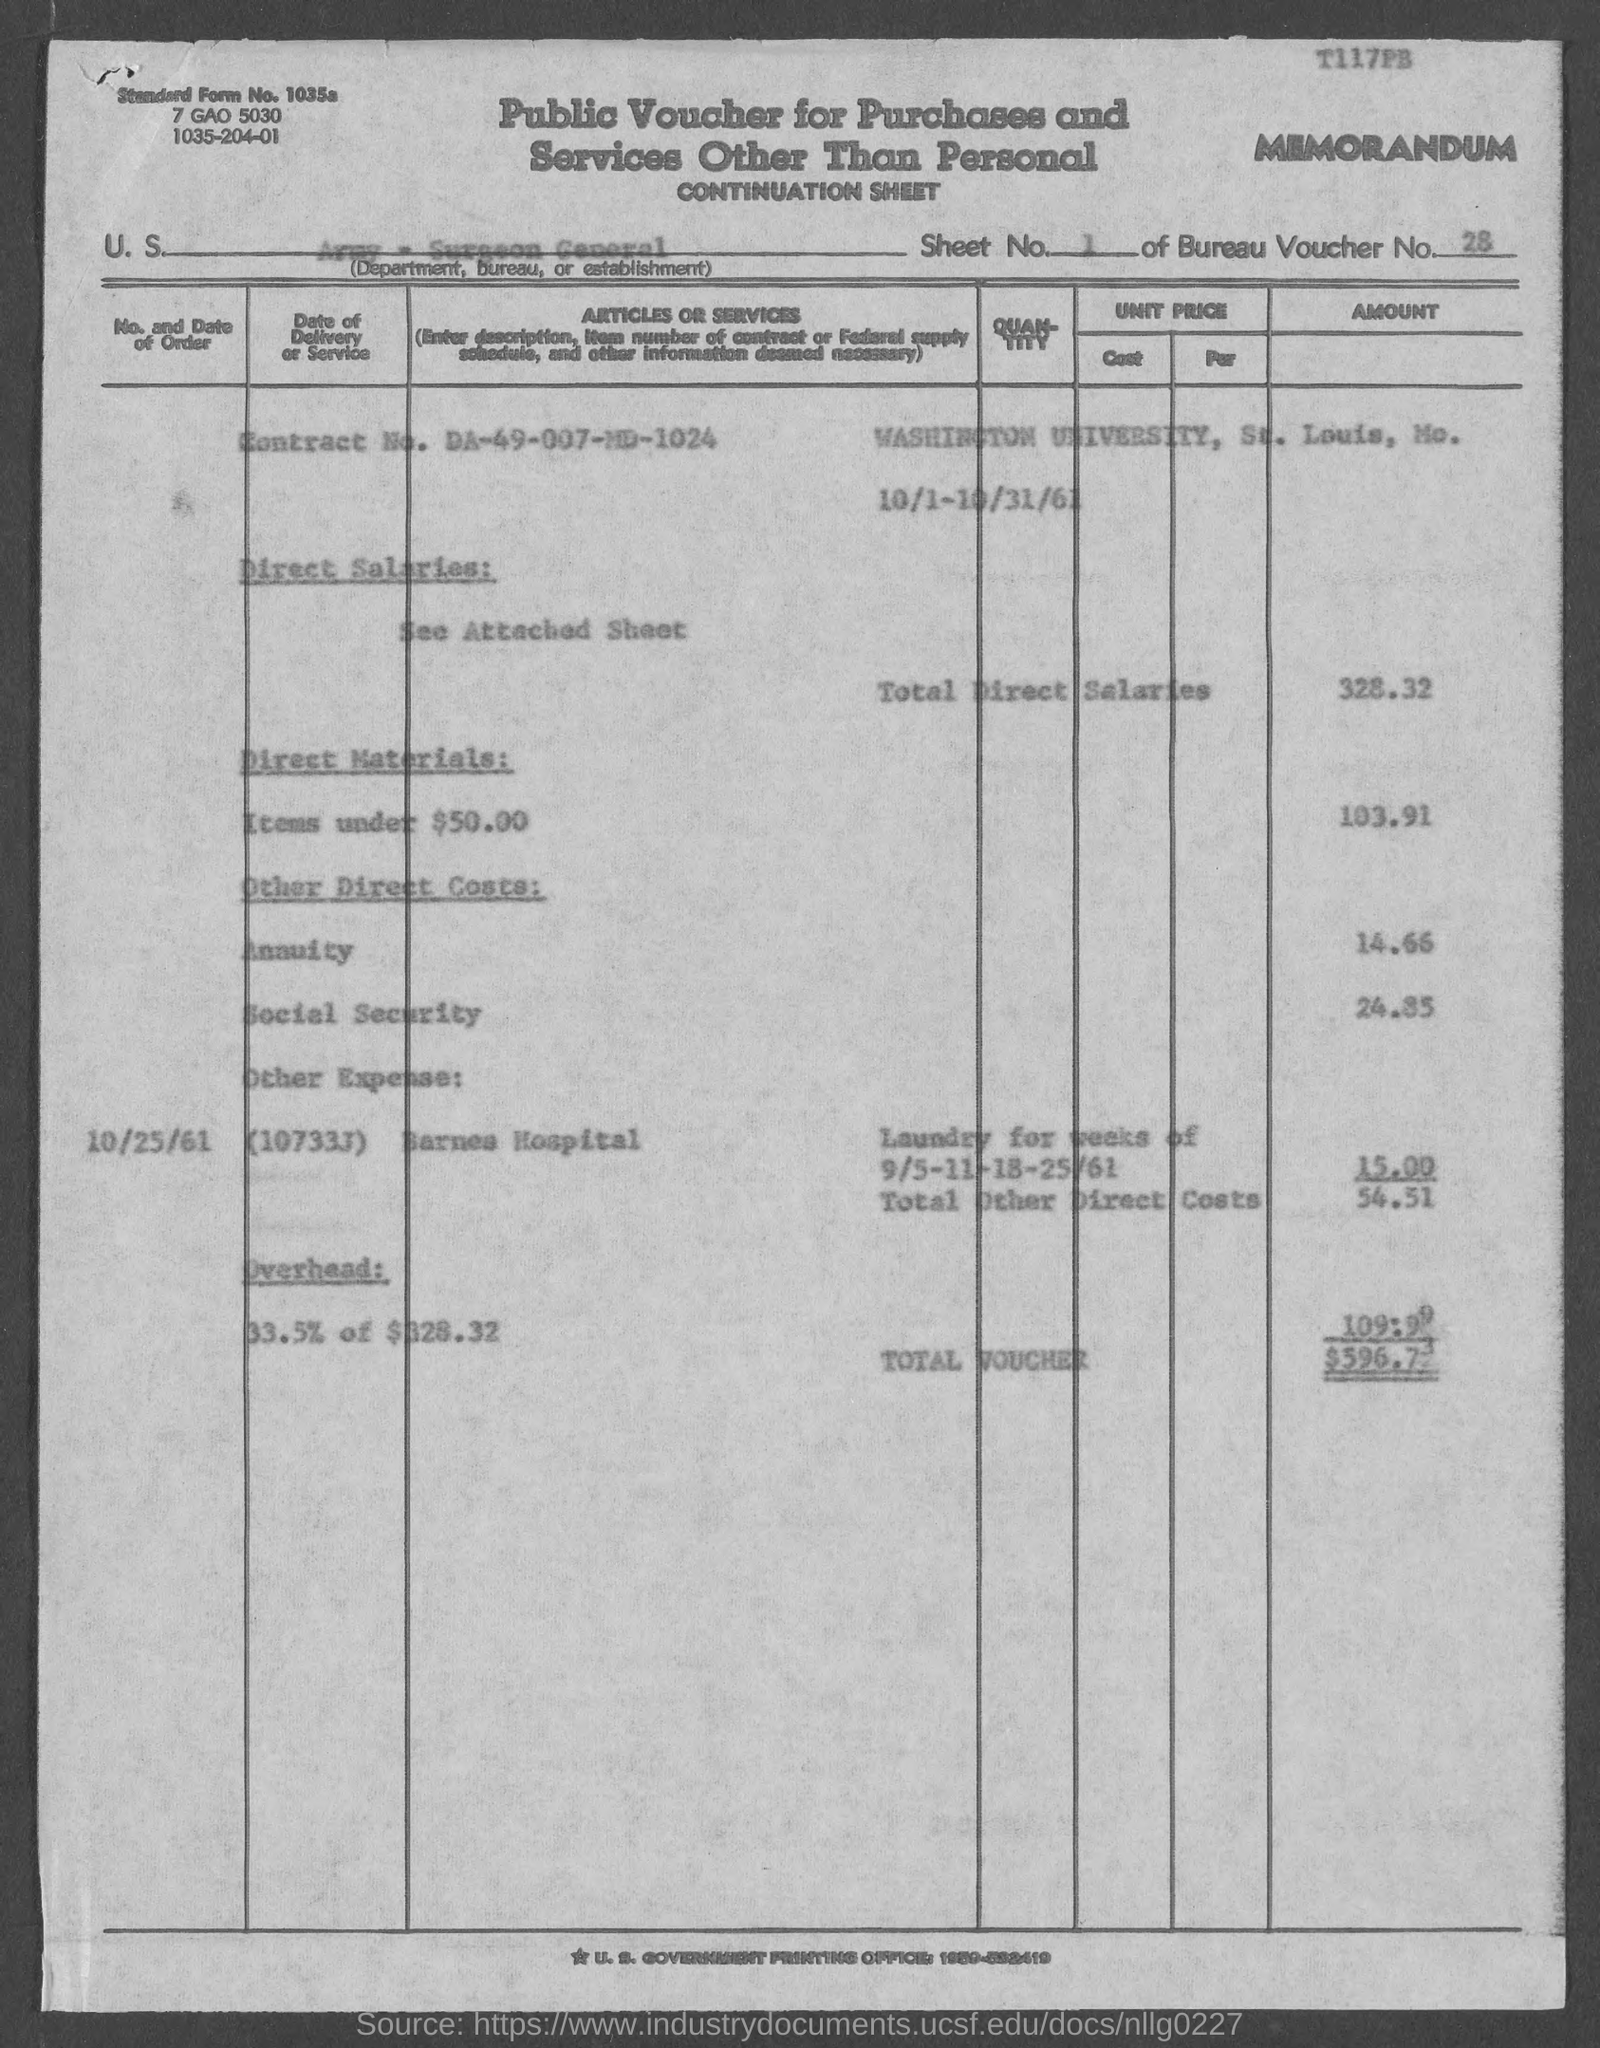Draw attention to some important aspects in this diagram. The direct materials cost for items under $50, as listed in the voucher, is 103.91. The total amount mentioned in the voucher is 596.73... What is the Bureau Voucher No. specified in the document? It is 28.. The Contract No. given in the voucher is DA-49-007-MD-1024. The standard form number given in the voucher is 1035a.. 